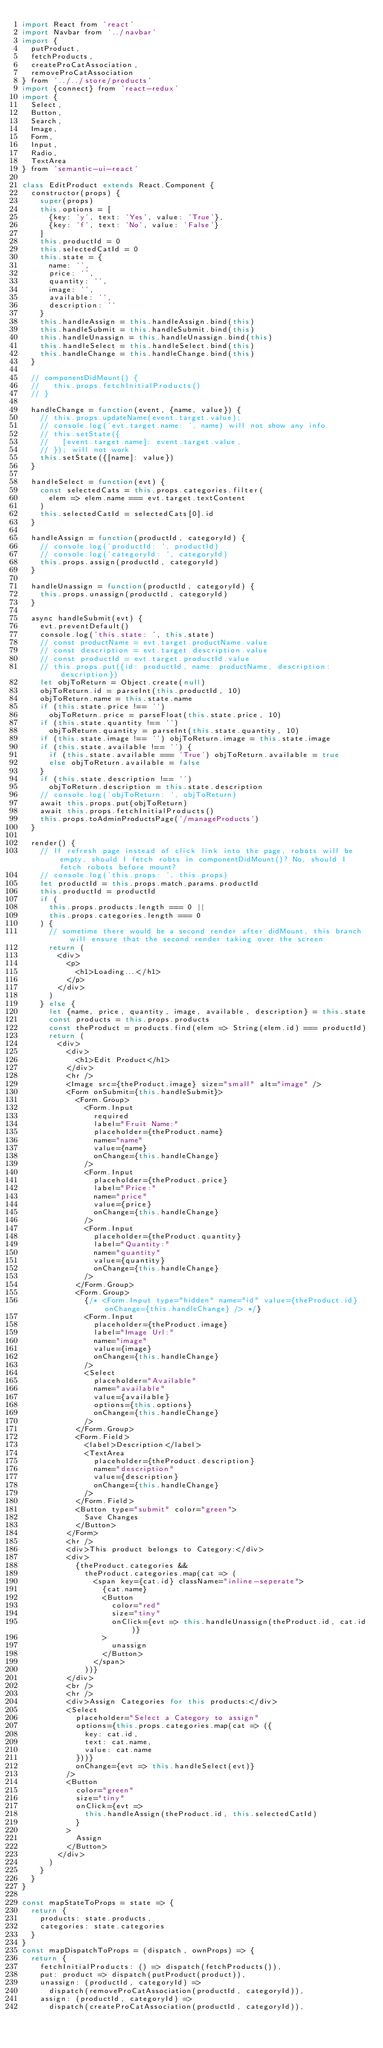Convert code to text. <code><loc_0><loc_0><loc_500><loc_500><_JavaScript_>import React from 'react'
import Navbar from '../navbar'
import {
  putProduct,
  fetchProducts,
  createProCatAssociation,
  removeProCatAssociation
} from '../../store/products'
import {connect} from 'react-redux'
import {
  Select,
  Button,
  Search,
  Image,
  Form,
  Input,
  Radio,
  TextArea
} from 'semantic-ui-react'

class EditProduct extends React.Component {
  constructor(props) {
    super(props)
    this.options = [
      {key: 'y', text: 'Yes', value: 'True'},
      {key: 'f', text: 'No', value: 'False'}
    ]
    this.productId = 0
    this.selectedCatId = 0
    this.state = {
      name: '',
      price: '',
      quantity: '',
      image: '',
      available: '',
      description: ''
    }
    this.handleAssign = this.handleAssign.bind(this)
    this.handleSubmit = this.handleSubmit.bind(this)
    this.handleUnassign = this.handleUnassign.bind(this)
    this.handleSelect = this.handleSelect.bind(this)
    this.handleChange = this.handleChange.bind(this)
  }

  // componentDidMount() {
  //   this.props.fetchInitialProducts()
  // }

  handleChange = function(event, {name, value}) {
    // this.props.updateName(event.target.value);
    // console.log('evt.target.name: ', name) will not show any info
    // this.setState({
    //   [event.target.name]: event.target.value,
    // }); will not work
    this.setState({[name]: value})
  }

  handleSelect = function(evt) {
    const selectedCats = this.props.categories.filter(
      elem => elem.name === evt.target.textContent
    )
    this.selectedCatId = selectedCats[0].id
  }

  handleAssign = function(productId, categoryId) {
    // console.log('productId: ', productId)
    // console.log('categoryId: ', categoryId)
    this.props.assign(productId, categoryId)
  }

  handleUnassign = function(productId, categoryId) {
    this.props.unassign(productId, categoryId)
  }

  async handleSubmit(evt) {
    evt.preventDefault()
    console.log('this.state: ', this.state)
    // const productName = evt.target.productName.value
    // const description = evt.target.description.value
    // const productId = evt.target.productId.value
    // this.props.put({id: productId, name: productName, description: description})
    let objToReturn = Object.create(null)
    objToReturn.id = parseInt(this.productId, 10)
    objToReturn.name = this.state.name
    if (this.state.price !== '')
      objToReturn.price = parseFloat(this.state.price, 10)
    if (this.state.quantity !== '')
      objToReturn.quantity = parseInt(this.state.quantity, 10)
    if (this.state.image !== '') objToReturn.image = this.state.image
    if (this.state.available !== '') {
      if (this.state.available === 'True') objToReturn.available = true
      else objToReturn.available = false
    }
    if (this.state.description !== '')
      objToReturn.description = this.state.description
    // console.log('objToReturn: ', objToReturn)
    await this.props.put(objToReturn)
    await this.props.fetchInitialProducts()
    this.props.toAdminProductsPage('/manageProducts')
  }

  render() {
    // If refresh page instead of click link into the page, robots will be empty, should I fetch robts in componentDidMount()? No, should I fetch robots before mount?
    // console.log('this.props: ', this.props)
    let productId = this.props.match.params.productId
    this.productId = productId
    if (
      this.props.products.length === 0 ||
      this.props.categories.length === 0
    ) {
      // sometime there would be a second render after didMount, this branch will ensure that the second render taking over the screen
      return (
        <div>
          <p>
            <h1>Loading...</h1>
          </p>
        </div>
      )
    } else {
      let {name, price, quantity, image, available, description} = this.state
      const products = this.props.products
      const theProduct = products.find(elem => String(elem.id) === productId)
      return (
        <div>
          <div>
            <h1>Edit Product</h1>
          </div>
          <hr />
          <Image src={theProduct.image} size="small" alt="image" />
          <Form onSubmit={this.handleSubmit}>
            <Form.Group>
              <Form.Input
                required
                label="Fruit Name:"
                placeholder={theProduct.name}
                name="name"
                value={name}
                onChange={this.handleChange}
              />
              <Form.Input
                placeholder={theProduct.price}
                label="Price:"
                name="price"
                value={price}
                onChange={this.handleChange}
              />
              <Form.Input
                placeholder={theProduct.quantity}
                label="Quantity:"
                name="quantity"
                value={quantity}
                onChange={this.handleChange}
              />
            </Form.Group>
            <Form.Group>
              {/* <Form.Input type="hidden" name="id" value={theProduct.id} onChange={this.handleChange} /> */}
              <Form.Input
                placeholder={theProduct.image}
                label="Image Url:"
                name="image"
                value={image}
                onChange={this.handleChange}
              />
              <Select
                placeholder="Available"
                name="available"
                value={available}
                options={this.options}
                onChange={this.handleChange}
              />
            </Form.Group>
            <Form.Field>
              <label>Description</label>
              <TextArea
                placeholder={theProduct.description}
                name="description"
                value={description}
                onChange={this.handleChange}
              />
            </Form.Field>
            <Button type="submit" color="green">
              Save Changes
            </Button>
          </Form>
          <hr />
          <div>This product belongs to Category:</div>
          <div>
            {theProduct.categories &&
              theProduct.categories.map(cat => (
                <span key={cat.id} className="inline-seperate">
                  {cat.name}
                  <Button
                    color="red"
                    size="tiny"
                    onClick={evt => this.handleUnassign(theProduct.id, cat.id)}
                  >
                    unassign
                  </Button>
                </span>
              ))}
          </div>
          <br />
          <hr />
          <div>Assign Categories for this products:</div>
          <Select
            placeholder="Select a Category to assign"
            options={this.props.categories.map(cat => ({
              key: cat.id,
              text: cat.name,
              value: cat.name
            }))}
            onChange={evt => this.handleSelect(evt)}
          />
          <Button
            color="green"
            size="tiny"
            onClick={evt =>
              this.handleAssign(theProduct.id, this.selectedCatId)
            }
          >
            Assign
          </Button>
        </div>
      )
    }
  }
}

const mapStateToProps = state => {
  return {
    products: state.products,
    categories: state.categories
  }
}
const mapDispatchToProps = (dispatch, ownProps) => {
  return {
    fetchInitialProducts: () => dispatch(fetchProducts()),
    put: product => dispatch(putProduct(product)),
    unassign: (productId, categoryId) =>
      dispatch(removeProCatAssociation(productId, categoryId)),
    assign: (productId, categoryId) =>
      dispatch(createProCatAssociation(productId, categoryId)),</code> 